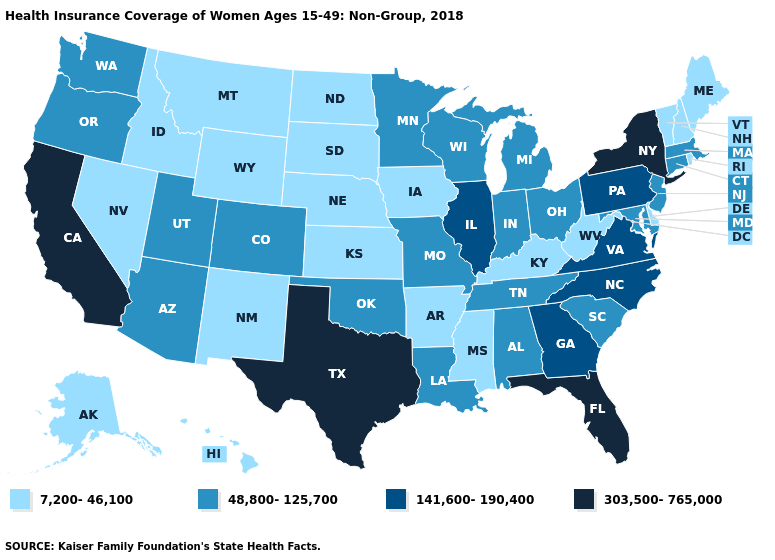What is the value of New York?
Short answer required. 303,500-765,000. What is the value of New Mexico?
Concise answer only. 7,200-46,100. Name the states that have a value in the range 303,500-765,000?
Give a very brief answer. California, Florida, New York, Texas. Name the states that have a value in the range 303,500-765,000?
Short answer required. California, Florida, New York, Texas. Does Alaska have the lowest value in the USA?
Concise answer only. Yes. Is the legend a continuous bar?
Short answer required. No. What is the value of Texas?
Answer briefly. 303,500-765,000. Does Arizona have the lowest value in the West?
Keep it brief. No. Does the map have missing data?
Be succinct. No. Does North Dakota have the same value as Washington?
Keep it brief. No. What is the highest value in the West ?
Short answer required. 303,500-765,000. What is the highest value in the USA?
Short answer required. 303,500-765,000. What is the lowest value in the USA?
Quick response, please. 7,200-46,100. Among the states that border Connecticut , which have the lowest value?
Be succinct. Rhode Island. What is the value of Texas?
Give a very brief answer. 303,500-765,000. 